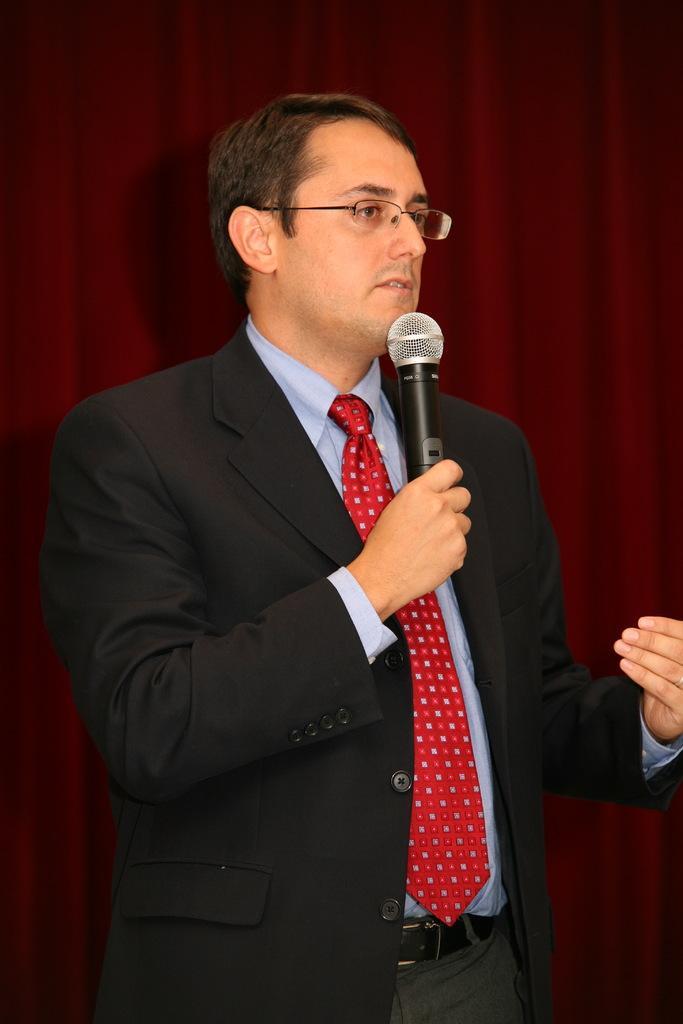Could you give a brief overview of what you see in this image? Here is a man standing and talking by holding a mike in his hand. At background I can see a maroon color cloth. 